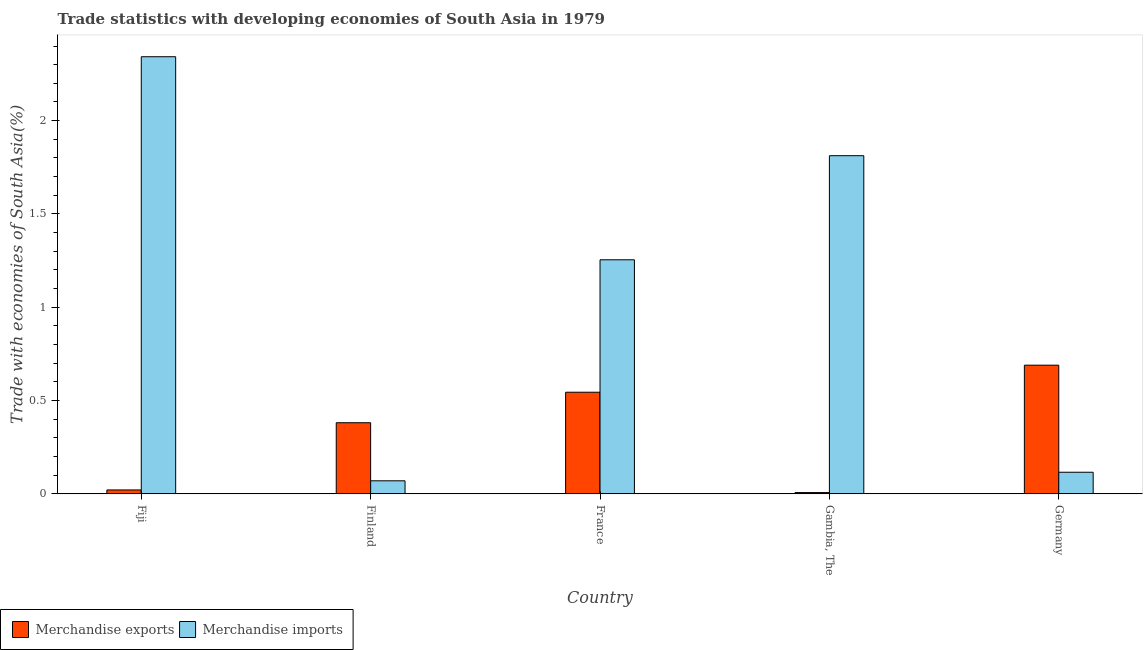How many different coloured bars are there?
Offer a very short reply. 2. Are the number of bars per tick equal to the number of legend labels?
Provide a succinct answer. Yes. Are the number of bars on each tick of the X-axis equal?
Provide a succinct answer. Yes. How many bars are there on the 1st tick from the left?
Ensure brevity in your answer.  2. What is the label of the 4th group of bars from the left?
Your response must be concise. Gambia, The. In how many cases, is the number of bars for a given country not equal to the number of legend labels?
Provide a succinct answer. 0. What is the merchandise exports in France?
Ensure brevity in your answer.  0.54. Across all countries, what is the maximum merchandise exports?
Your answer should be compact. 0.69. Across all countries, what is the minimum merchandise imports?
Make the answer very short. 0.07. In which country was the merchandise exports maximum?
Your response must be concise. Germany. In which country was the merchandise exports minimum?
Offer a very short reply. Gambia, The. What is the total merchandise imports in the graph?
Make the answer very short. 5.59. What is the difference between the merchandise imports in Gambia, The and that in Germany?
Keep it short and to the point. 1.7. What is the difference between the merchandise exports in Fiji and the merchandise imports in France?
Your answer should be very brief. -1.23. What is the average merchandise imports per country?
Make the answer very short. 1.12. What is the difference between the merchandise exports and merchandise imports in Gambia, The?
Offer a very short reply. -1.81. In how many countries, is the merchandise exports greater than 2.1 %?
Offer a terse response. 0. What is the ratio of the merchandise imports in Gambia, The to that in Germany?
Make the answer very short. 15.64. Is the merchandise exports in Finland less than that in Gambia, The?
Your answer should be very brief. No. What is the difference between the highest and the second highest merchandise exports?
Your answer should be very brief. 0.14. What is the difference between the highest and the lowest merchandise imports?
Provide a short and direct response. 2.27. What does the 1st bar from the left in France represents?
Offer a very short reply. Merchandise exports. How many bars are there?
Keep it short and to the point. 10. How many countries are there in the graph?
Your response must be concise. 5. Does the graph contain any zero values?
Offer a terse response. No. How many legend labels are there?
Provide a short and direct response. 2. How are the legend labels stacked?
Ensure brevity in your answer.  Horizontal. What is the title of the graph?
Keep it short and to the point. Trade statistics with developing economies of South Asia in 1979. What is the label or title of the X-axis?
Keep it short and to the point. Country. What is the label or title of the Y-axis?
Offer a very short reply. Trade with economies of South Asia(%). What is the Trade with economies of South Asia(%) of Merchandise exports in Fiji?
Your answer should be compact. 0.02. What is the Trade with economies of South Asia(%) in Merchandise imports in Fiji?
Your answer should be compact. 2.34. What is the Trade with economies of South Asia(%) in Merchandise exports in Finland?
Keep it short and to the point. 0.38. What is the Trade with economies of South Asia(%) in Merchandise imports in Finland?
Offer a terse response. 0.07. What is the Trade with economies of South Asia(%) of Merchandise exports in France?
Keep it short and to the point. 0.54. What is the Trade with economies of South Asia(%) in Merchandise imports in France?
Ensure brevity in your answer.  1.25. What is the Trade with economies of South Asia(%) of Merchandise exports in Gambia, The?
Ensure brevity in your answer.  0.01. What is the Trade with economies of South Asia(%) in Merchandise imports in Gambia, The?
Offer a very short reply. 1.81. What is the Trade with economies of South Asia(%) of Merchandise exports in Germany?
Keep it short and to the point. 0.69. What is the Trade with economies of South Asia(%) in Merchandise imports in Germany?
Your answer should be compact. 0.12. Across all countries, what is the maximum Trade with economies of South Asia(%) of Merchandise exports?
Provide a succinct answer. 0.69. Across all countries, what is the maximum Trade with economies of South Asia(%) of Merchandise imports?
Provide a succinct answer. 2.34. Across all countries, what is the minimum Trade with economies of South Asia(%) of Merchandise exports?
Give a very brief answer. 0.01. Across all countries, what is the minimum Trade with economies of South Asia(%) of Merchandise imports?
Make the answer very short. 0.07. What is the total Trade with economies of South Asia(%) of Merchandise exports in the graph?
Provide a succinct answer. 1.64. What is the total Trade with economies of South Asia(%) in Merchandise imports in the graph?
Ensure brevity in your answer.  5.59. What is the difference between the Trade with economies of South Asia(%) of Merchandise exports in Fiji and that in Finland?
Provide a succinct answer. -0.36. What is the difference between the Trade with economies of South Asia(%) in Merchandise imports in Fiji and that in Finland?
Offer a terse response. 2.27. What is the difference between the Trade with economies of South Asia(%) of Merchandise exports in Fiji and that in France?
Your answer should be very brief. -0.52. What is the difference between the Trade with economies of South Asia(%) of Merchandise imports in Fiji and that in France?
Your answer should be compact. 1.09. What is the difference between the Trade with economies of South Asia(%) of Merchandise exports in Fiji and that in Gambia, The?
Offer a very short reply. 0.01. What is the difference between the Trade with economies of South Asia(%) of Merchandise imports in Fiji and that in Gambia, The?
Offer a very short reply. 0.53. What is the difference between the Trade with economies of South Asia(%) of Merchandise exports in Fiji and that in Germany?
Offer a very short reply. -0.67. What is the difference between the Trade with economies of South Asia(%) of Merchandise imports in Fiji and that in Germany?
Provide a short and direct response. 2.23. What is the difference between the Trade with economies of South Asia(%) in Merchandise exports in Finland and that in France?
Ensure brevity in your answer.  -0.16. What is the difference between the Trade with economies of South Asia(%) in Merchandise imports in Finland and that in France?
Offer a very short reply. -1.18. What is the difference between the Trade with economies of South Asia(%) of Merchandise exports in Finland and that in Gambia, The?
Make the answer very short. 0.37. What is the difference between the Trade with economies of South Asia(%) of Merchandise imports in Finland and that in Gambia, The?
Your answer should be compact. -1.74. What is the difference between the Trade with economies of South Asia(%) in Merchandise exports in Finland and that in Germany?
Give a very brief answer. -0.31. What is the difference between the Trade with economies of South Asia(%) in Merchandise imports in Finland and that in Germany?
Keep it short and to the point. -0.05. What is the difference between the Trade with economies of South Asia(%) in Merchandise exports in France and that in Gambia, The?
Provide a short and direct response. 0.54. What is the difference between the Trade with economies of South Asia(%) in Merchandise imports in France and that in Gambia, The?
Ensure brevity in your answer.  -0.56. What is the difference between the Trade with economies of South Asia(%) in Merchandise exports in France and that in Germany?
Ensure brevity in your answer.  -0.14. What is the difference between the Trade with economies of South Asia(%) in Merchandise imports in France and that in Germany?
Give a very brief answer. 1.14. What is the difference between the Trade with economies of South Asia(%) in Merchandise exports in Gambia, The and that in Germany?
Your answer should be very brief. -0.68. What is the difference between the Trade with economies of South Asia(%) of Merchandise imports in Gambia, The and that in Germany?
Ensure brevity in your answer.  1.7. What is the difference between the Trade with economies of South Asia(%) of Merchandise exports in Fiji and the Trade with economies of South Asia(%) of Merchandise imports in Finland?
Keep it short and to the point. -0.05. What is the difference between the Trade with economies of South Asia(%) in Merchandise exports in Fiji and the Trade with economies of South Asia(%) in Merchandise imports in France?
Ensure brevity in your answer.  -1.23. What is the difference between the Trade with economies of South Asia(%) of Merchandise exports in Fiji and the Trade with economies of South Asia(%) of Merchandise imports in Gambia, The?
Your answer should be very brief. -1.79. What is the difference between the Trade with economies of South Asia(%) of Merchandise exports in Fiji and the Trade with economies of South Asia(%) of Merchandise imports in Germany?
Provide a short and direct response. -0.09. What is the difference between the Trade with economies of South Asia(%) of Merchandise exports in Finland and the Trade with economies of South Asia(%) of Merchandise imports in France?
Your response must be concise. -0.87. What is the difference between the Trade with economies of South Asia(%) in Merchandise exports in Finland and the Trade with economies of South Asia(%) in Merchandise imports in Gambia, The?
Give a very brief answer. -1.43. What is the difference between the Trade with economies of South Asia(%) of Merchandise exports in Finland and the Trade with economies of South Asia(%) of Merchandise imports in Germany?
Provide a succinct answer. 0.27. What is the difference between the Trade with economies of South Asia(%) in Merchandise exports in France and the Trade with economies of South Asia(%) in Merchandise imports in Gambia, The?
Give a very brief answer. -1.27. What is the difference between the Trade with economies of South Asia(%) of Merchandise exports in France and the Trade with economies of South Asia(%) of Merchandise imports in Germany?
Provide a short and direct response. 0.43. What is the difference between the Trade with economies of South Asia(%) of Merchandise exports in Gambia, The and the Trade with economies of South Asia(%) of Merchandise imports in Germany?
Offer a terse response. -0.11. What is the average Trade with economies of South Asia(%) in Merchandise exports per country?
Your answer should be compact. 0.33. What is the average Trade with economies of South Asia(%) of Merchandise imports per country?
Provide a short and direct response. 1.12. What is the difference between the Trade with economies of South Asia(%) of Merchandise exports and Trade with economies of South Asia(%) of Merchandise imports in Fiji?
Provide a short and direct response. -2.32. What is the difference between the Trade with economies of South Asia(%) in Merchandise exports and Trade with economies of South Asia(%) in Merchandise imports in Finland?
Your answer should be compact. 0.31. What is the difference between the Trade with economies of South Asia(%) of Merchandise exports and Trade with economies of South Asia(%) of Merchandise imports in France?
Make the answer very short. -0.71. What is the difference between the Trade with economies of South Asia(%) of Merchandise exports and Trade with economies of South Asia(%) of Merchandise imports in Gambia, The?
Your answer should be compact. -1.81. What is the difference between the Trade with economies of South Asia(%) in Merchandise exports and Trade with economies of South Asia(%) in Merchandise imports in Germany?
Keep it short and to the point. 0.57. What is the ratio of the Trade with economies of South Asia(%) in Merchandise exports in Fiji to that in Finland?
Provide a short and direct response. 0.06. What is the ratio of the Trade with economies of South Asia(%) in Merchandise imports in Fiji to that in Finland?
Offer a very short reply. 33.5. What is the ratio of the Trade with economies of South Asia(%) of Merchandise exports in Fiji to that in France?
Your answer should be very brief. 0.04. What is the ratio of the Trade with economies of South Asia(%) in Merchandise imports in Fiji to that in France?
Provide a succinct answer. 1.87. What is the ratio of the Trade with economies of South Asia(%) of Merchandise exports in Fiji to that in Gambia, The?
Make the answer very short. 3.04. What is the ratio of the Trade with economies of South Asia(%) in Merchandise imports in Fiji to that in Gambia, The?
Your answer should be compact. 1.29. What is the ratio of the Trade with economies of South Asia(%) of Merchandise exports in Fiji to that in Germany?
Your answer should be compact. 0.03. What is the ratio of the Trade with economies of South Asia(%) of Merchandise imports in Fiji to that in Germany?
Your response must be concise. 20.21. What is the ratio of the Trade with economies of South Asia(%) of Merchandise exports in Finland to that in France?
Provide a short and direct response. 0.7. What is the ratio of the Trade with economies of South Asia(%) of Merchandise imports in Finland to that in France?
Your response must be concise. 0.06. What is the ratio of the Trade with economies of South Asia(%) of Merchandise exports in Finland to that in Gambia, The?
Your response must be concise. 55.2. What is the ratio of the Trade with economies of South Asia(%) in Merchandise imports in Finland to that in Gambia, The?
Give a very brief answer. 0.04. What is the ratio of the Trade with economies of South Asia(%) in Merchandise exports in Finland to that in Germany?
Your answer should be compact. 0.55. What is the ratio of the Trade with economies of South Asia(%) of Merchandise imports in Finland to that in Germany?
Provide a short and direct response. 0.6. What is the ratio of the Trade with economies of South Asia(%) of Merchandise exports in France to that in Gambia, The?
Provide a short and direct response. 78.86. What is the ratio of the Trade with economies of South Asia(%) in Merchandise imports in France to that in Gambia, The?
Your answer should be compact. 0.69. What is the ratio of the Trade with economies of South Asia(%) in Merchandise exports in France to that in Germany?
Make the answer very short. 0.79. What is the ratio of the Trade with economies of South Asia(%) of Merchandise imports in France to that in Germany?
Make the answer very short. 10.82. What is the ratio of the Trade with economies of South Asia(%) of Merchandise exports in Gambia, The to that in Germany?
Your answer should be compact. 0.01. What is the ratio of the Trade with economies of South Asia(%) in Merchandise imports in Gambia, The to that in Germany?
Make the answer very short. 15.64. What is the difference between the highest and the second highest Trade with economies of South Asia(%) of Merchandise exports?
Give a very brief answer. 0.14. What is the difference between the highest and the second highest Trade with economies of South Asia(%) of Merchandise imports?
Your answer should be compact. 0.53. What is the difference between the highest and the lowest Trade with economies of South Asia(%) of Merchandise exports?
Ensure brevity in your answer.  0.68. What is the difference between the highest and the lowest Trade with economies of South Asia(%) of Merchandise imports?
Offer a very short reply. 2.27. 